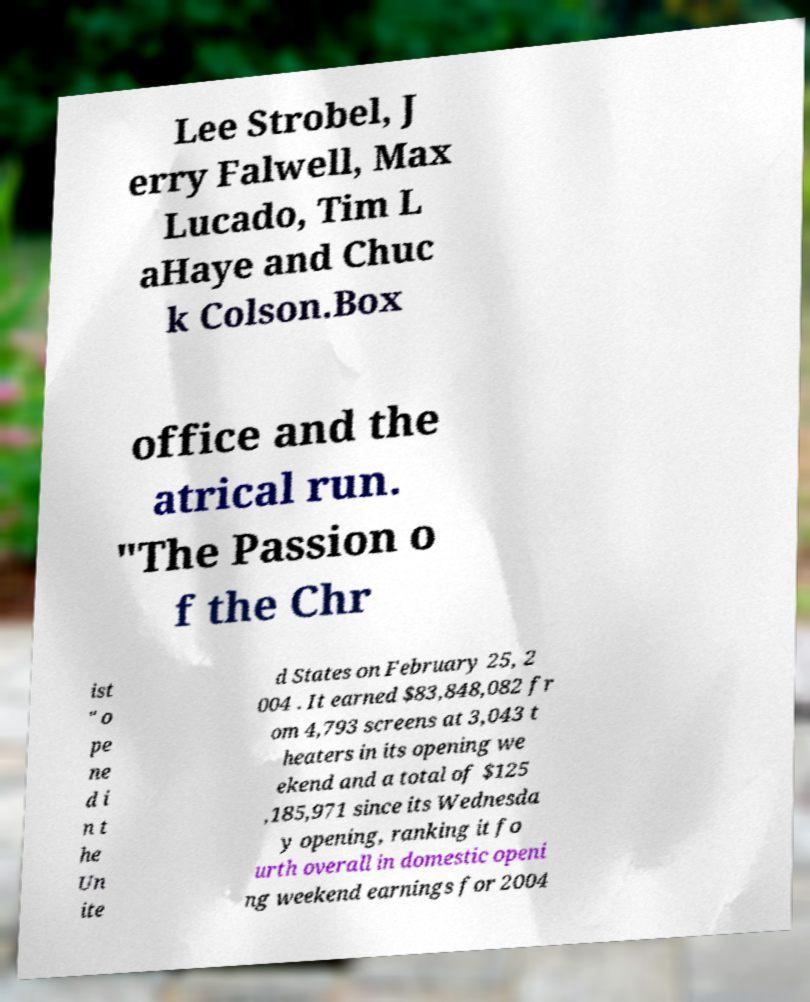I need the written content from this picture converted into text. Can you do that? Lee Strobel, J erry Falwell, Max Lucado, Tim L aHaye and Chuc k Colson.Box office and the atrical run. "The Passion o f the Chr ist " o pe ne d i n t he Un ite d States on February 25, 2 004 . It earned $83,848,082 fr om 4,793 screens at 3,043 t heaters in its opening we ekend and a total of $125 ,185,971 since its Wednesda y opening, ranking it fo urth overall in domestic openi ng weekend earnings for 2004 